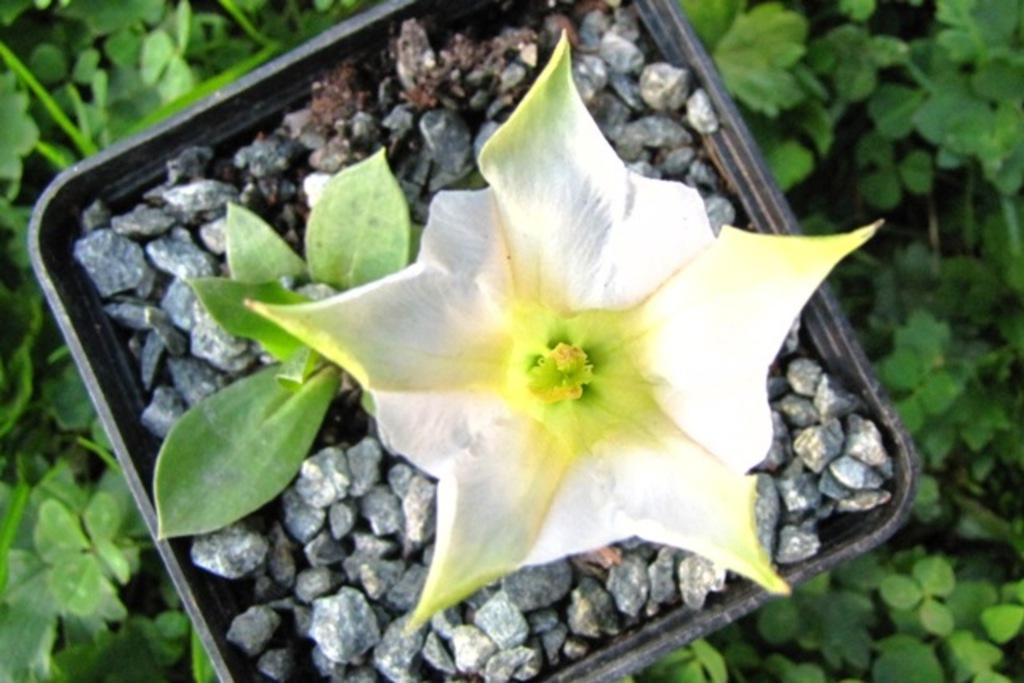What is the main subject of the image? There is a flower in the image. How is the flower displayed in the image? The flower is placed in a basket. What is the basket resting on in the image? The basket is on stones. What type of natural environment is visible in the image? There is grass visible around the basket. What type of coach can be seen driving through the grass in the image? There is no coach present in the image; it features a flower in a basket on stones with grass around it. How does the plot of land affect the growth of the flower in the image? The image does not provide information about the plot of land or its effect on the flower's growth. 